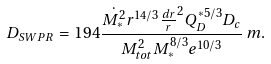Convert formula to latex. <formula><loc_0><loc_0><loc_500><loc_500>D _ { S W P R } = 1 9 4 \frac { \dot { M _ { * } ^ { 2 } } r ^ { 1 4 / 3 } \frac { d r } { r } ^ { 2 } Q _ { D } ^ { * 5 / 3 } D _ { c } } { M _ { t o t } ^ { 2 } M _ { * } ^ { 8 / 3 } e ^ { 1 0 / 3 } } \, m .</formula> 